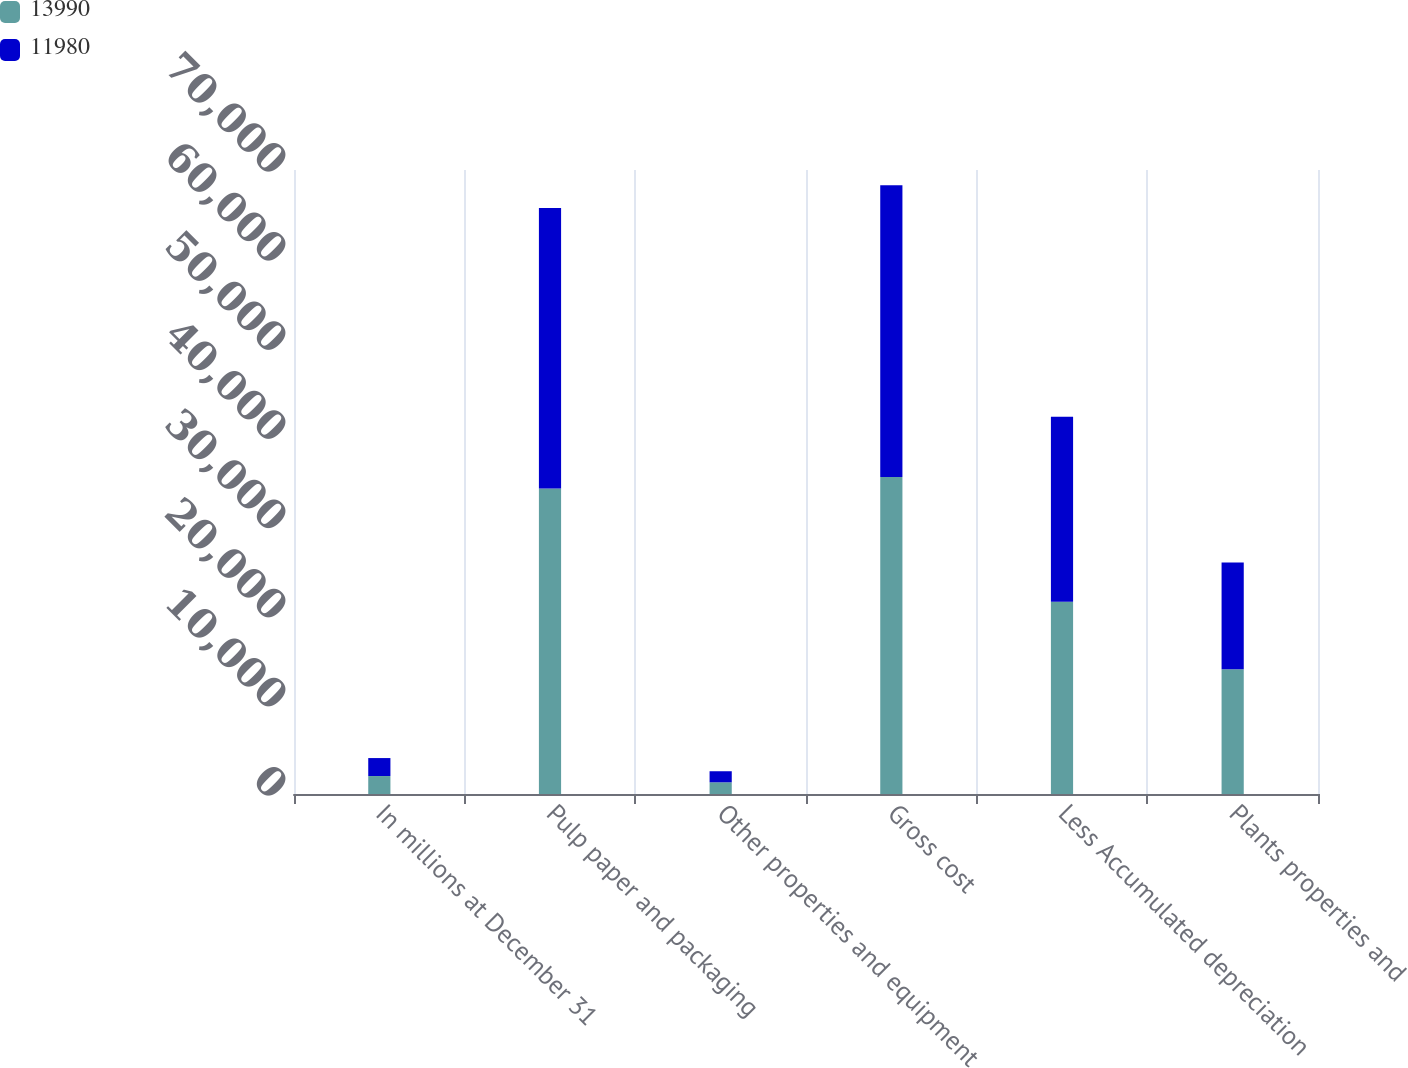Convert chart. <chart><loc_0><loc_0><loc_500><loc_500><stacked_bar_chart><ecel><fcel>In millions at December 31<fcel>Pulp paper and packaging<fcel>Other properties and equipment<fcel>Gross cost<fcel>Less Accumulated depreciation<fcel>Plants properties and<nl><fcel>13990<fcel>2016<fcel>34259<fcel>1311<fcel>35570<fcel>21580<fcel>13990<nl><fcel>11980<fcel>2015<fcel>31466<fcel>1242<fcel>32708<fcel>20728<fcel>11980<nl></chart> 